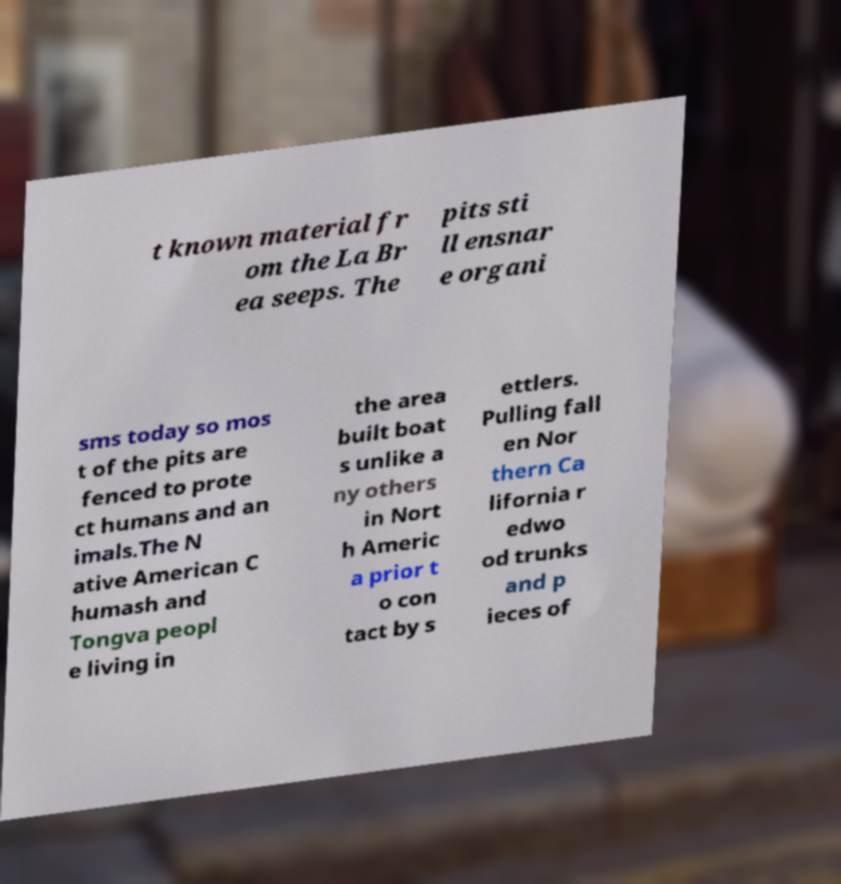There's text embedded in this image that I need extracted. Can you transcribe it verbatim? t known material fr om the La Br ea seeps. The pits sti ll ensnar e organi sms today so mos t of the pits are fenced to prote ct humans and an imals.The N ative American C humash and Tongva peopl e living in the area built boat s unlike a ny others in Nort h Americ a prior t o con tact by s ettlers. Pulling fall en Nor thern Ca lifornia r edwo od trunks and p ieces of 